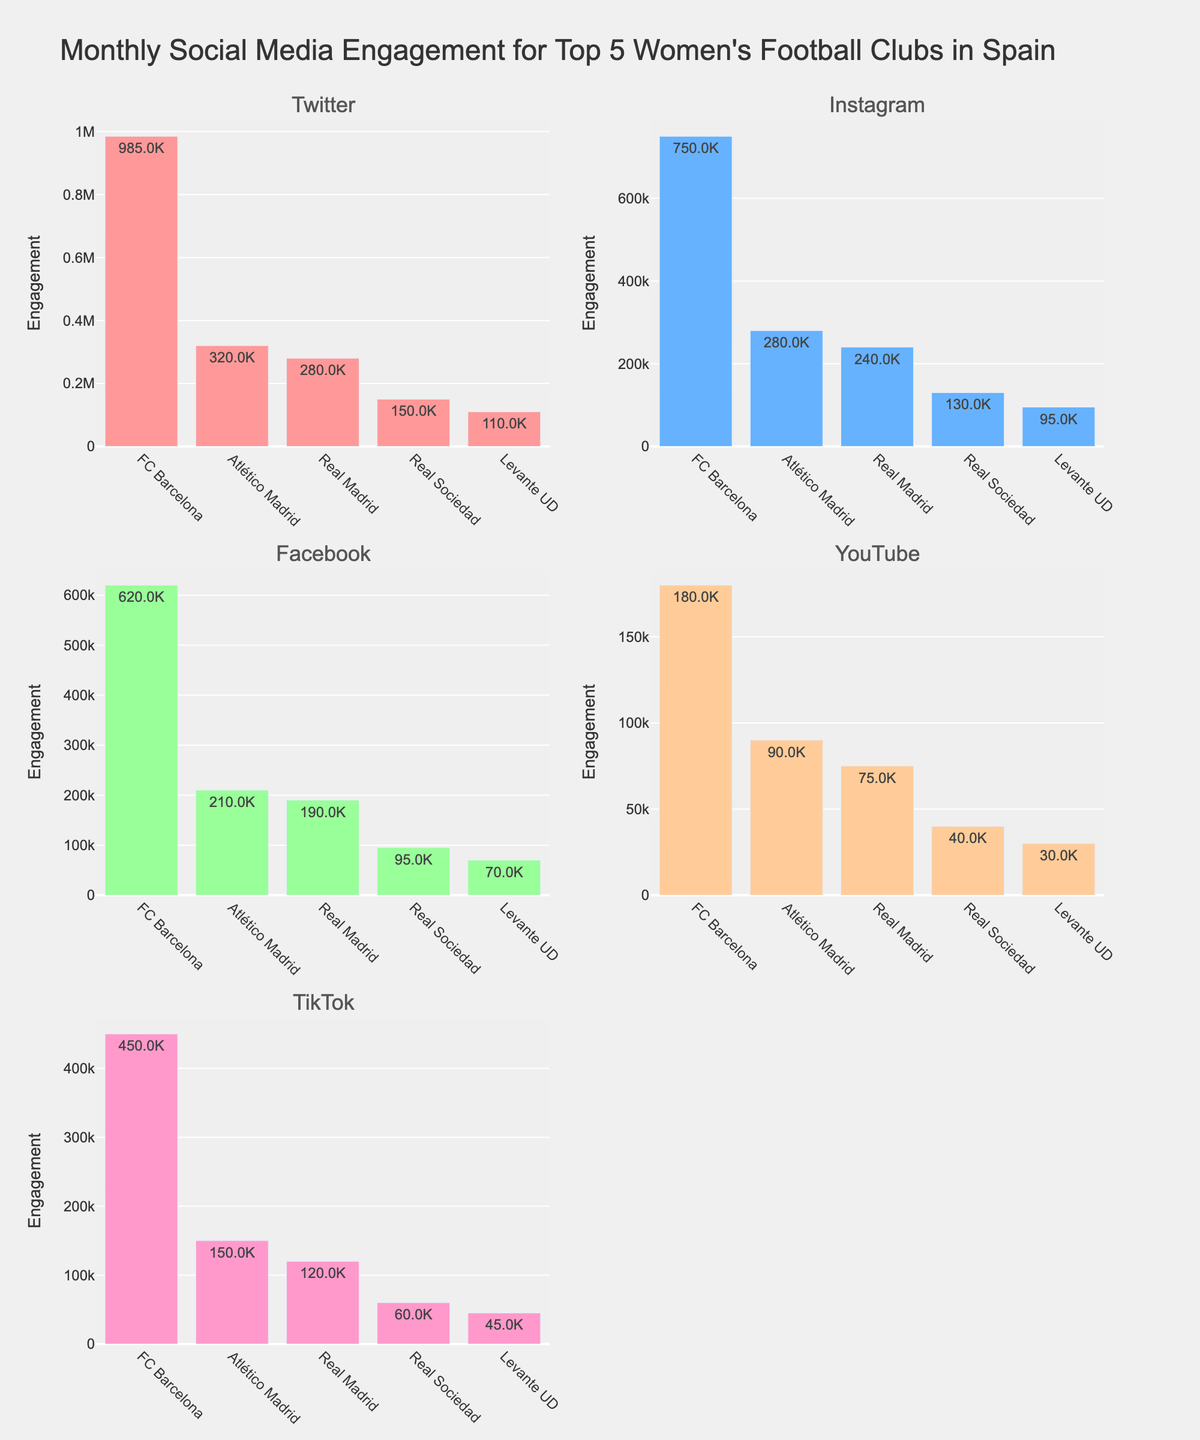What is the title of the figure? The title of the figure is usually found at the top of the plot. It provides a summary of what the data represents. In this case, we are looking for the descriptive text that explains the overall content of the plot.
Answer: "Money Laundering Trends in Major U.S. Cities (2013-2022)" How many cities are compared in the figure? Count the number of unique subplot titles; each subplot represents a different city.
Answer: 3 Which money laundering method shows the highest frequency in New York in 2013? Look at the subplot for New York and identify the highest point on the y-axis in the year 2013. The color of the line and legend helps identify the method.
Answer: Cash Smuggling How does the frequency of Crypto-based money laundering in Los Angeles change from 2016 to 2022? Locate the subplot for Los Angeles, find the data points for Crypto-based money laundering for 2016 and 2022, and observe the change in the y-axis values.
Answer: It increases Which city had the highest frequency of real estate-based money laundering in 2022? Compare the 2022 data points for real estate-based money laundering across all city subplots to find the highest value.
Answer: New York Did structuring increase or decrease in Chicago from 2013 to 2019? Look at the subplot for Chicago, and observe the data points for structuring in the years 2013 and 2019. Compare the values to determine if there was an increase or decrease.
Answer: Increase What is the overall trend of cash smuggling in New York from 2013 to 2022? Observe the subplot for New York and track the line for cash smuggling from 2013 to 2022. Note if it generally increases, decreases, or stays constant.
Answer: Decreases Which method of money laundering consistently shows an upward trend in New York from 2013 to 2022? Examine the subplot for New York and identify which line shows a consistent increase across all years.
Answer: Crypto What is the difference in real estate-based money laundering between Chicago and Los Angeles in 2022? Find the data points for real estate-based money laundering in both Chicago and Los Angeles in 2022, then subtract the value of Chicago from Los Angeles.
Answer: 4 Which city shows the most variation in trade-based money laundering over the years? Check all subplots and compare the range of y-axis values for trade-based money laundering across the years for each city.
Answer: New York 